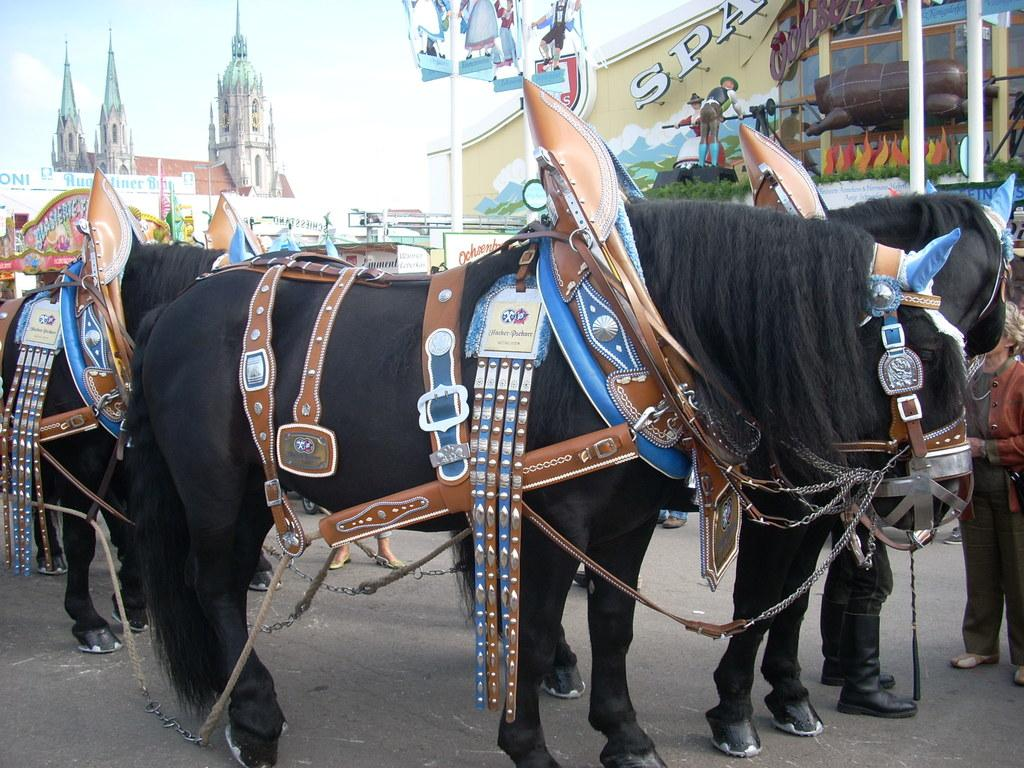What animals can be seen on the road in the image? There are horses on the road in the image. What structures can be seen in the background of the image? There is a building, a pole, and a church in the background of the image. Are there any people visible in the image? Yes, there are persons in the background of the image. What part of the natural environment is visible in the image? The sky is visible in the background of the image. How do the rabbits rub against the pole in the image? There are no rabbits present in the image, so this action cannot be observed. 